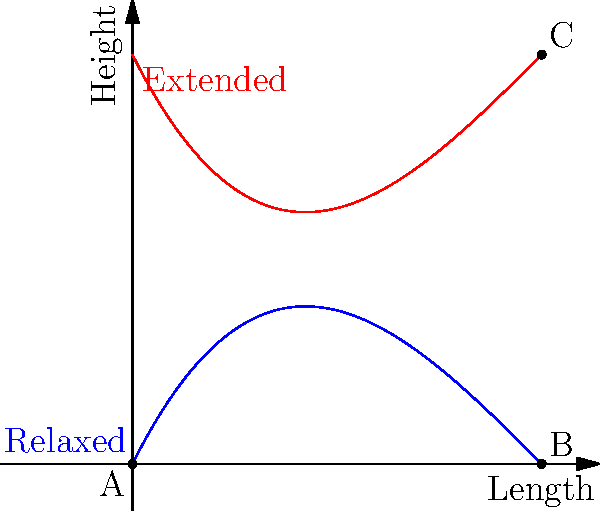The graph shows the simplified spinal curvature of a cat in relaxed (blue) and extended (red) positions during a jump. If the cat's spine length is 10 units, what is the approximate difference in vertical displacement between points B and C? To solve this problem, we need to follow these steps:

1. Identify the points of interest:
   - Point A: The base of the spine (0,0)
   - Point B: The tip of the spine in relaxed position (10, f(10))
   - Point C: The tip of the spine in extended position (10, g(10))

2. Calculate the y-coordinate (height) of point B:
   $f(10) = 0.01(10)^3 - 0.3(10)^2 + 2(10) = 10 - 30 + 20 = 0$

3. Calculate the y-coordinate (height) of point C:
   $g(10) = -0.01(10)^3 + 0.3(10)^2 - 2(10) + 10 = -10 + 30 - 20 + 10 = 10$

4. Calculate the difference in vertical displacement:
   Vertical displacement = y-coordinate of C - y-coordinate of B
   $= 10 - 0 = 10$ units

Therefore, the approximate difference in vertical displacement between points B and C is 10 units.
Answer: 10 units 